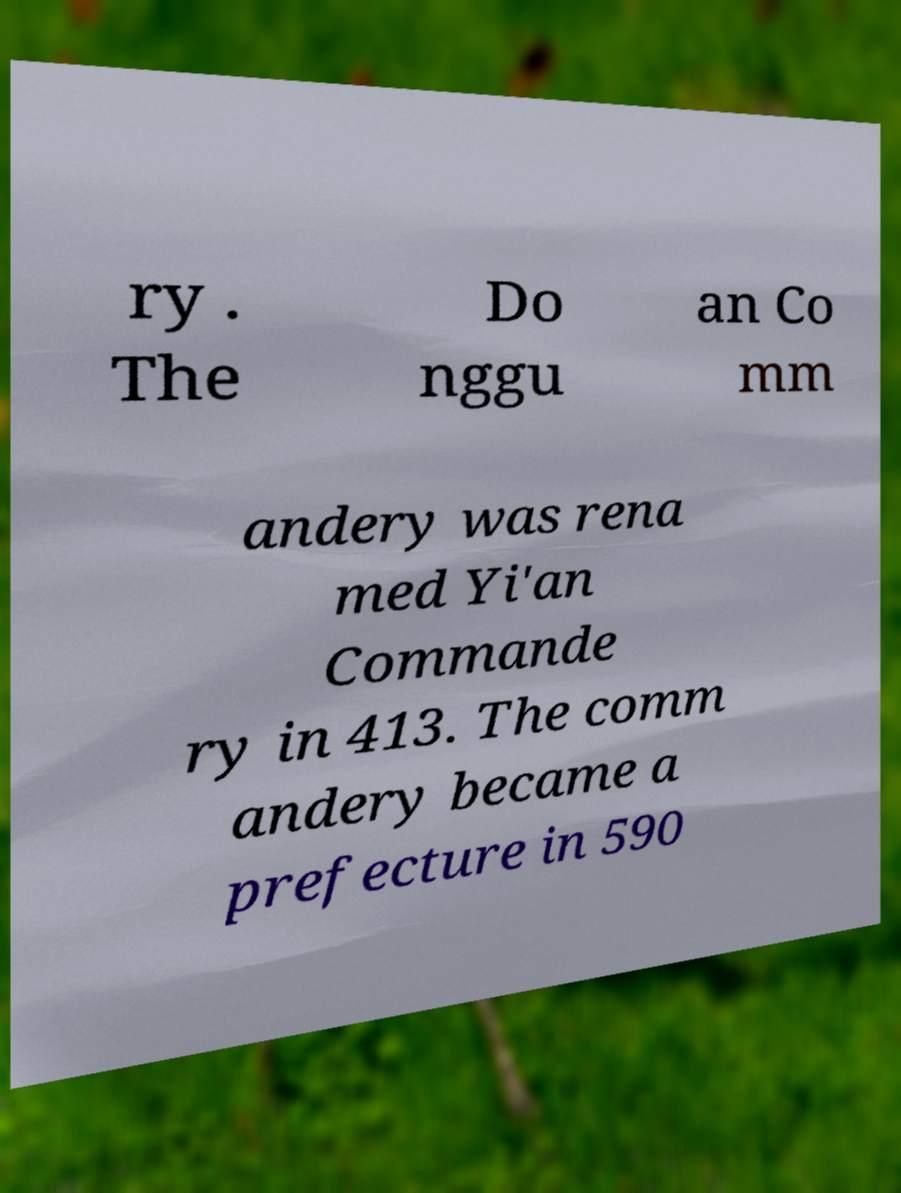I need the written content from this picture converted into text. Can you do that? ry . The Do nggu an Co mm andery was rena med Yi'an Commande ry in 413. The comm andery became a prefecture in 590 